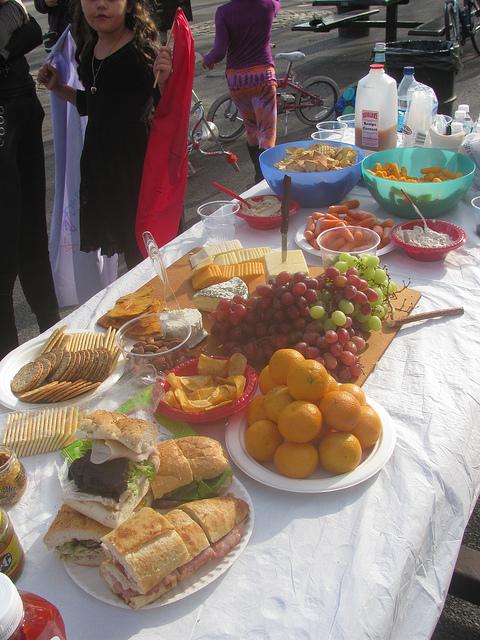Have the people already eaten?
Be succinct. No. IS there a bike in the picture?
Short answer required. Yes. Is the picture taken indoor or outdoor?
Quick response, please. Outdoor. 